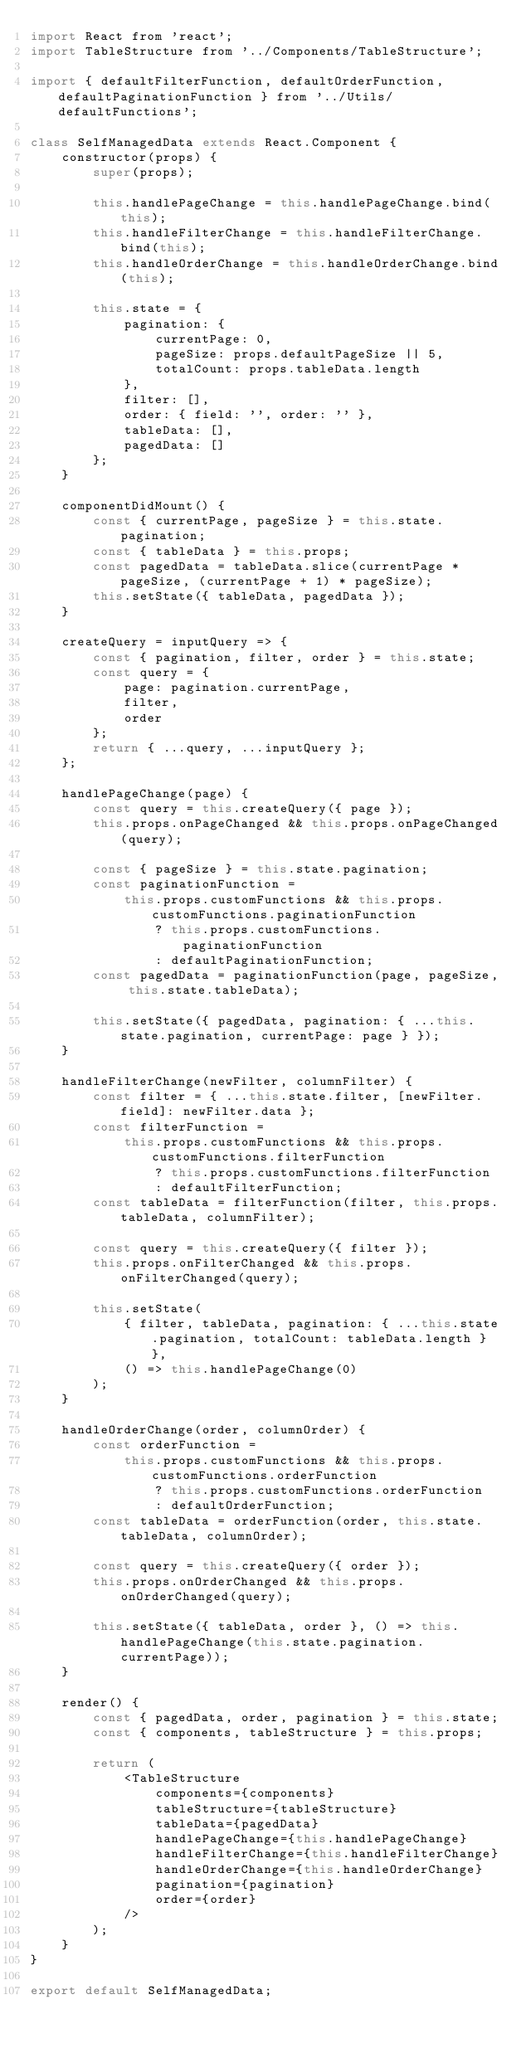<code> <loc_0><loc_0><loc_500><loc_500><_JavaScript_>import React from 'react';
import TableStructure from '../Components/TableStructure';

import { defaultFilterFunction, defaultOrderFunction, defaultPaginationFunction } from '../Utils/defaultFunctions';

class SelfManagedData extends React.Component {
    constructor(props) {
        super(props);

        this.handlePageChange = this.handlePageChange.bind(this);
        this.handleFilterChange = this.handleFilterChange.bind(this);
        this.handleOrderChange = this.handleOrderChange.bind(this);

        this.state = {
            pagination: {
                currentPage: 0,
                pageSize: props.defaultPageSize || 5,
                totalCount: props.tableData.length
            },
            filter: [],
            order: { field: '', order: '' },
            tableData: [],
            pagedData: []
        };
    }

    componentDidMount() {
        const { currentPage, pageSize } = this.state.pagination;
        const { tableData } = this.props;
        const pagedData = tableData.slice(currentPage * pageSize, (currentPage + 1) * pageSize);
        this.setState({ tableData, pagedData });
    }

    createQuery = inputQuery => {
        const { pagination, filter, order } = this.state;
        const query = {
            page: pagination.currentPage,
            filter,
            order
        };
        return { ...query, ...inputQuery };
    };

    handlePageChange(page) {
        const query = this.createQuery({ page });
        this.props.onPageChanged && this.props.onPageChanged(query);

        const { pageSize } = this.state.pagination;
        const paginationFunction =
            this.props.customFunctions && this.props.customFunctions.paginationFunction
                ? this.props.customFunctions.paginationFunction
                : defaultPaginationFunction;
        const pagedData = paginationFunction(page, pageSize, this.state.tableData);

        this.setState({ pagedData, pagination: { ...this.state.pagination, currentPage: page } });
    }

    handleFilterChange(newFilter, columnFilter) {
        const filter = { ...this.state.filter, [newFilter.field]: newFilter.data };
        const filterFunction =
            this.props.customFunctions && this.props.customFunctions.filterFunction
                ? this.props.customFunctions.filterFunction
                : defaultFilterFunction;
        const tableData = filterFunction(filter, this.props.tableData, columnFilter);

        const query = this.createQuery({ filter });
        this.props.onFilterChanged && this.props.onFilterChanged(query);

        this.setState(
            { filter, tableData, pagination: { ...this.state.pagination, totalCount: tableData.length } },
            () => this.handlePageChange(0)
        );
    }

    handleOrderChange(order, columnOrder) {
        const orderFunction =
            this.props.customFunctions && this.props.customFunctions.orderFunction
                ? this.props.customFunctions.orderFunction
                : defaultOrderFunction;
        const tableData = orderFunction(order, this.state.tableData, columnOrder);

        const query = this.createQuery({ order });
        this.props.onOrderChanged && this.props.onOrderChanged(query);

        this.setState({ tableData, order }, () => this.handlePageChange(this.state.pagination.currentPage));
    }

    render() {
        const { pagedData, order, pagination } = this.state;
        const { components, tableStructure } = this.props;

        return (
            <TableStructure
                components={components}
                tableStructure={tableStructure}
                tableData={pagedData}
                handlePageChange={this.handlePageChange}
                handleFilterChange={this.handleFilterChange}
                handleOrderChange={this.handleOrderChange}
                pagination={pagination}
                order={order}
            />
        );
    }
}

export default SelfManagedData;
</code> 